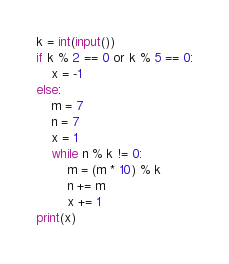Convert code to text. <code><loc_0><loc_0><loc_500><loc_500><_Python_>k = int(input())
if k % 2 == 0 or k % 5 == 0:
    x = -1
else:
    m = 7
    n = 7
    x = 1
    while n % k != 0:
        m = (m * 10) % k
        n += m
        x += 1
print(x)</code> 